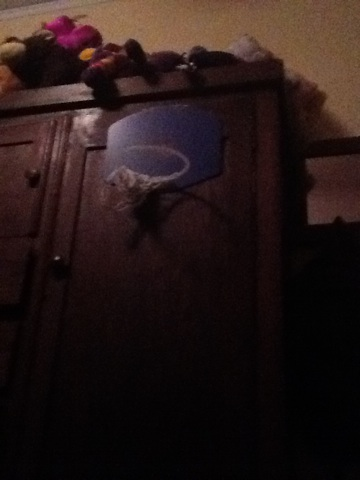What is that? The object in the image appears to be a basketball hoop attached to a piece of furniture, possibly a wardrobe or cabinet. This mini hoop is commonly used for indoor play, allowing people to practice basketball shots within the comfort of their home. 